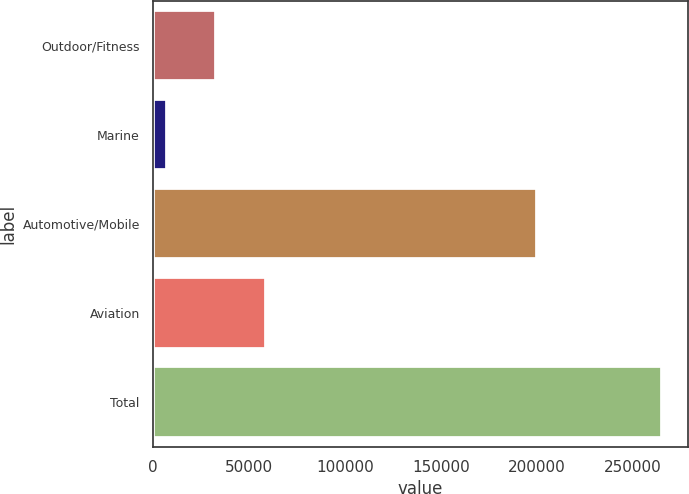<chart> <loc_0><loc_0><loc_500><loc_500><bar_chart><fcel>Outdoor/Fitness<fcel>Marine<fcel>Automotive/Mobile<fcel>Aviation<fcel>Total<nl><fcel>33045.6<fcel>7248<fcel>199946<fcel>58843.2<fcel>265224<nl></chart> 